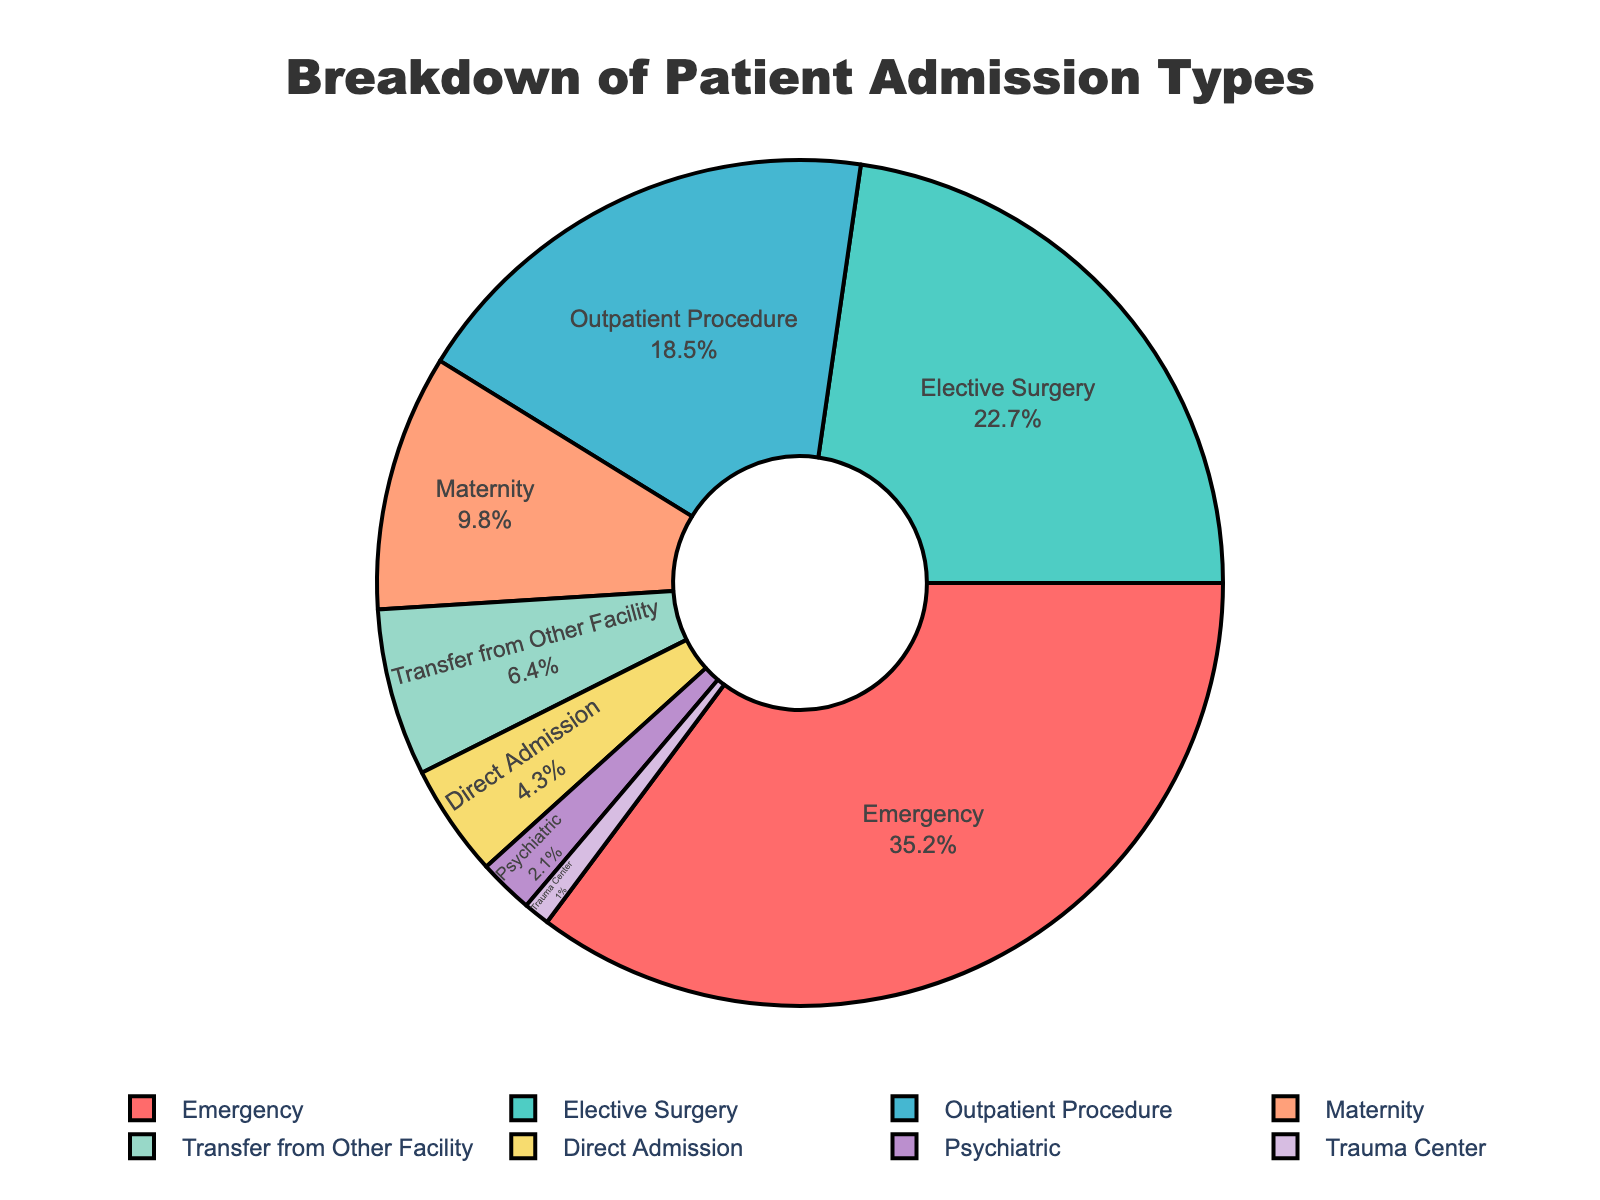What percentage of admissions are for emergency situations? To find the percentage of admissions for emergency situations, locate the segment labeled "Emergency" in the pie chart. The percentage is shown both in the segment label and in the legend.
Answer: 35.2% Which admission type has the smallest percentage of patients? Identify the segment with the smallest share of the pie chart. The "Trauma Center" segment is the smallest, and it should also be the last in the legend.
Answer: Trauma Center What is the combined percentage of Elective Surgery and Outpatient Procedure admissions? First, find the percentages for "Elective Surgery" and "Outpatient Procedure." They are 22.7% and 18.5% respectively. Then, add them together: 22.7% + 18.5% = 41.2%.
Answer: 41.2% Is the percentage of Psychiatric admissions greater than 2%? Look for the "Psychiatric" segment in the pie chart. The label shows it is 2.1%, which is slightly greater than 2%.
Answer: Yes How much larger is the percentage of Emergency admissions compared to Maternity admissions? Locate the percentages for "Emergency" (35.2%) and "Maternity" (9.8%). Calculate the difference: 35.2% - 9.8% = 25.4%.
Answer: 25.4% What is the total percentage of admissions for Maternity, Transfer from Other Facility, and Direct Admission combined? Add the percentages for "Maternity" (9.8%), "Transfer from Other Facility" (6.4%), and "Direct Admission" (4.3%): 9.8% + 6.4% + 4.3% = 20.5%.
Answer: 20.5% How does the percentage of Emergency admissions compare to Elective Surgery admissions? Look at the percentages for "Emergency" (35.2%) and "Elective Surgery" (22.7%). Emergency is higher.
Answer: Emergency is higher Which slice of the pie chart is colored red, and what is its percentage? Focus on the visual attribute of the red color slice in the pie chart. The red slice corresponds to "Emergency" admissions, which are at 35.2%.
Answer: Emergency, 35.2% By what factor is the percentage of Outpatient Procedure admissions larger than Psychiatric admissions? Divide the percentage of "Outpatient Procedure" (18.5%) by the percentage of "Psychiatric" (2.1%): 18.5% / 2.1 ≈ 8.81.
Answer: 8.81 What admission types collectively make up more than half of the admissions? Sum the percentages of the largest segments until you exceed 50%. Emergency (35.2%) + Elective Surgery (22.7%) = 57.9%, which is more than half. These two types alone suffice.
Answer: Emergency, Elective Surgery 